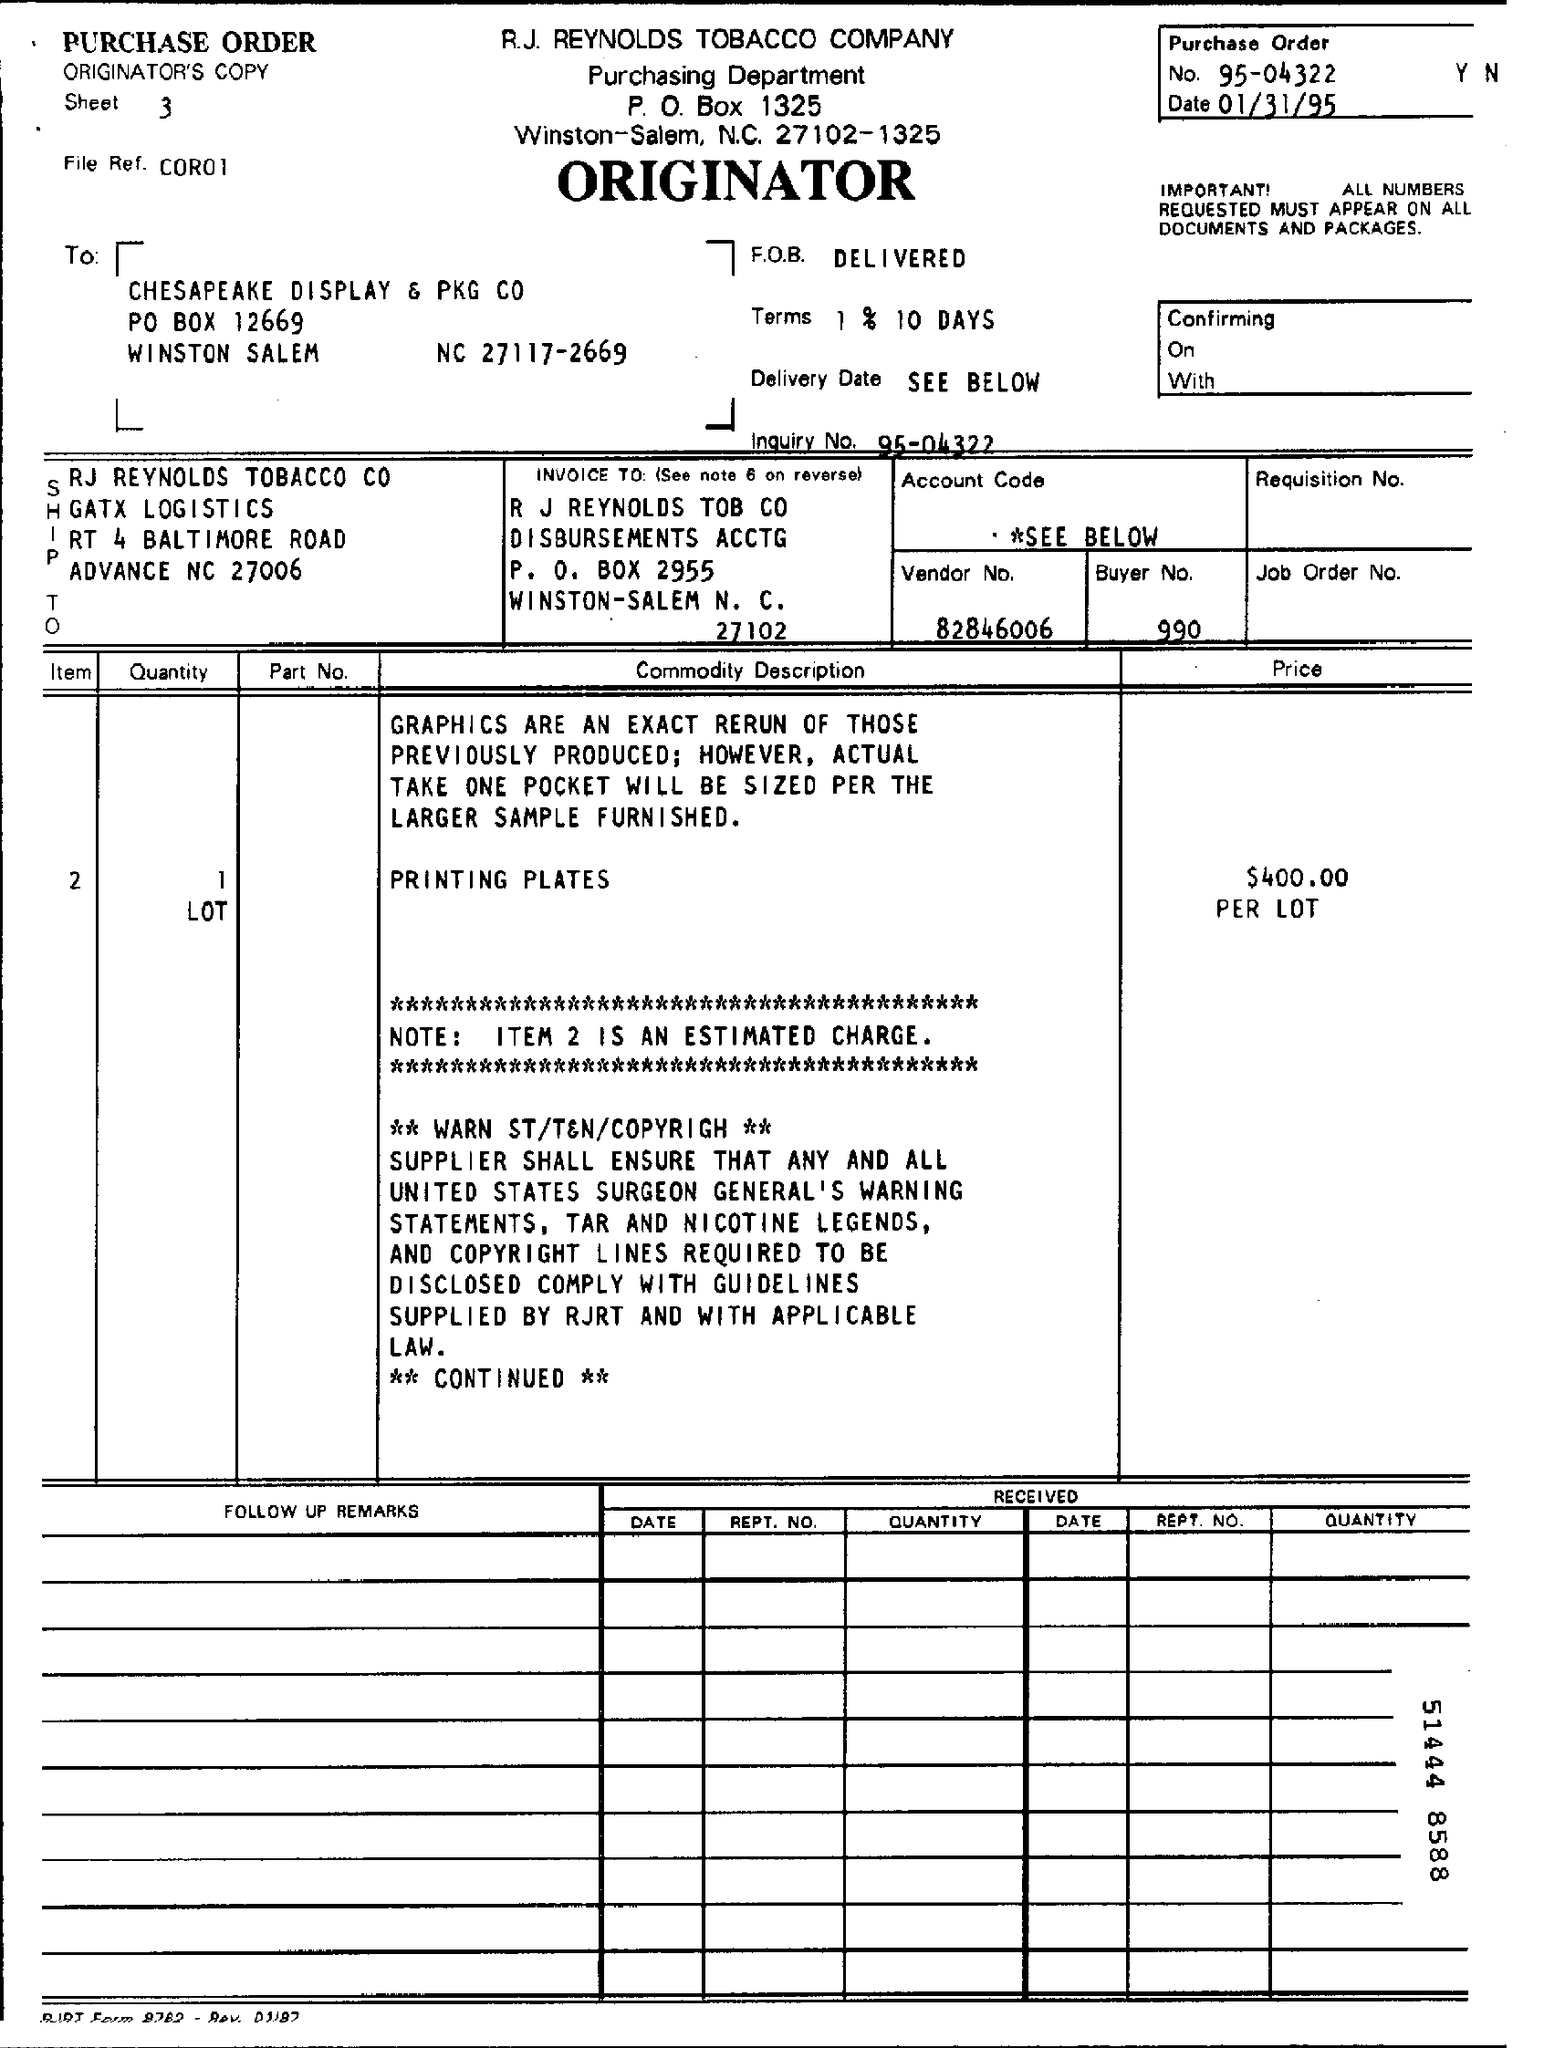What is "Note"?
Provide a succinct answer. Item 2 is an estimated charge. What is price per lot?
Offer a terse response. $ 400.00. What is purchase order no:?
Your answer should be compact. 95-04322. What is mentioned as "Terms"?
Offer a very short reply. 1% 10 Days. 